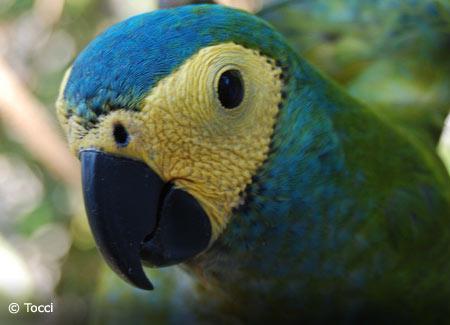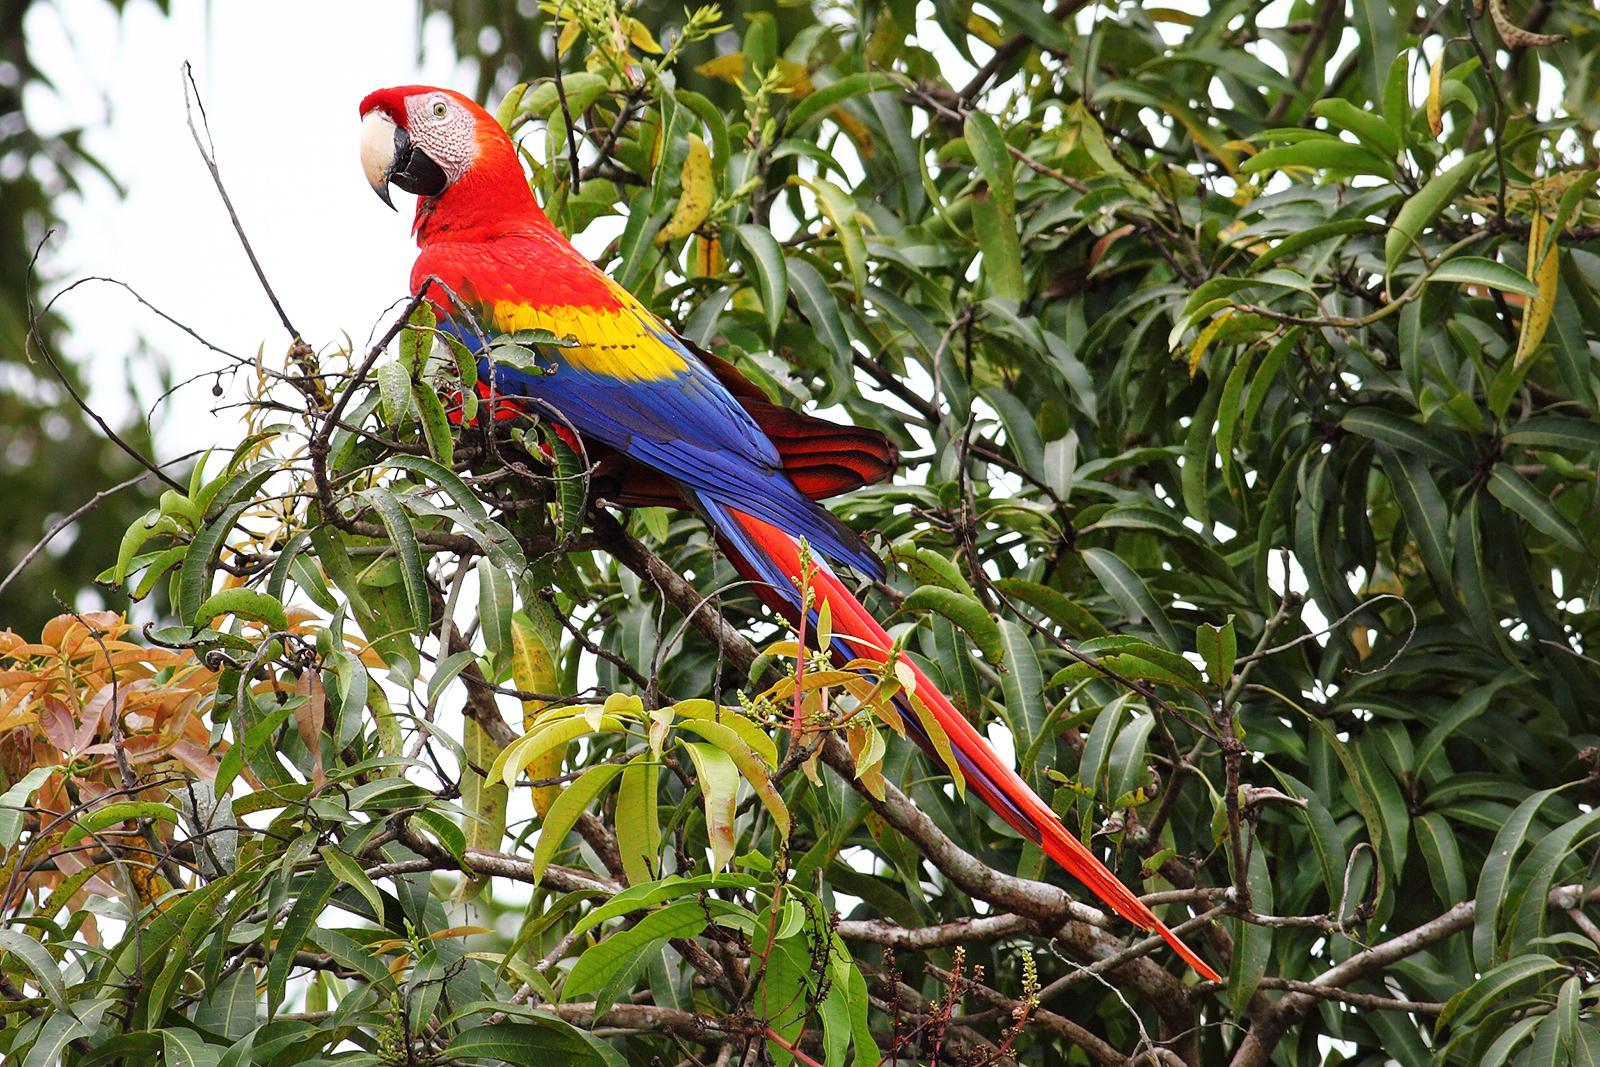The first image is the image on the left, the second image is the image on the right. Analyze the images presented: Is the assertion "The left image shows a parrot with wings extended in flight." valid? Answer yes or no. No. 